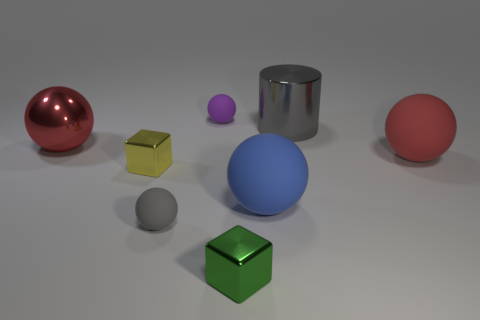Add 1 gray objects. How many objects exist? 9 Subtract all small purple spheres. How many spheres are left? 4 Subtract all cylinders. How many objects are left? 7 Subtract 2 cubes. How many cubes are left? 0 Subtract all yellow cylinders. How many red balls are left? 2 Subtract 1 gray balls. How many objects are left? 7 Subtract all green blocks. Subtract all brown cylinders. How many blocks are left? 1 Subtract all small brown metal cylinders. Subtract all large blue rubber spheres. How many objects are left? 7 Add 8 tiny gray rubber spheres. How many tiny gray rubber spheres are left? 9 Add 4 purple spheres. How many purple spheres exist? 5 